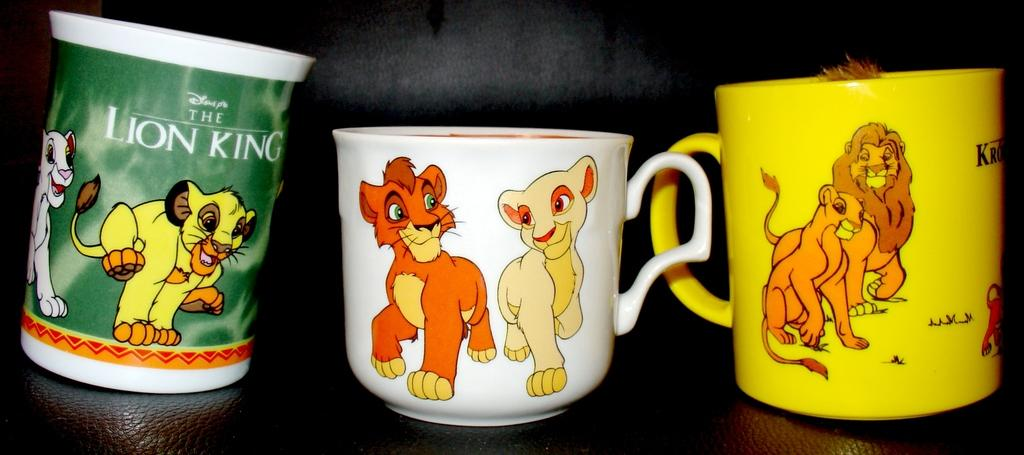What objects are present in the image? There are cups in the image. Where are the cups located? The cups are placed on a sofa. What time is displayed on the clock in the image? There is no clock present in the image; only cups and a sofa are visible. 